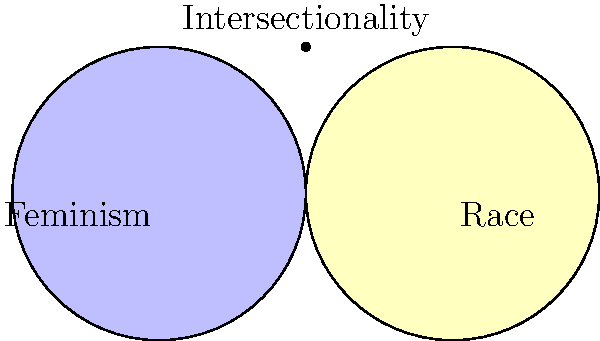Analyze the Venn diagram depicting the intersection of feminism and race. What concept does the overlapping area represent, and how does it challenge traditional feminist discourse? 1. The Venn diagram shows two circles: one representing feminism and the other representing race.

2. The overlapping area between these circles represents intersectionality, a concept introduced by Kimberlé Crenshaw in 1989.

3. Intersectionality recognizes that various forms of social categorization, such as race, class, and gender, do not exist separately but are interwoven and influence each other.

4. This concept challenges traditional feminist discourse by highlighting that:
   a) Women's experiences are not universal and are shaped by multiple, intersecting identities.
   b) Oppression and discrimination can be compounded by these intersecting identities.

5. Intersectionality argues that focusing solely on gender-based oppression ignores the unique challenges faced by women of color, working-class women, LGBTQ+ women, and other marginalized groups.

6. By acknowledging intersectionality, feminist theory and activism become more inclusive and effective in addressing the diverse experiences and needs of all women.

7. The diagram illustrates how race and feminism are distinct but interconnected issues, with intersectionality serving as a crucial bridge between them.
Answer: Intersectionality; it challenges the universality of women's experiences and highlights compounded oppression. 